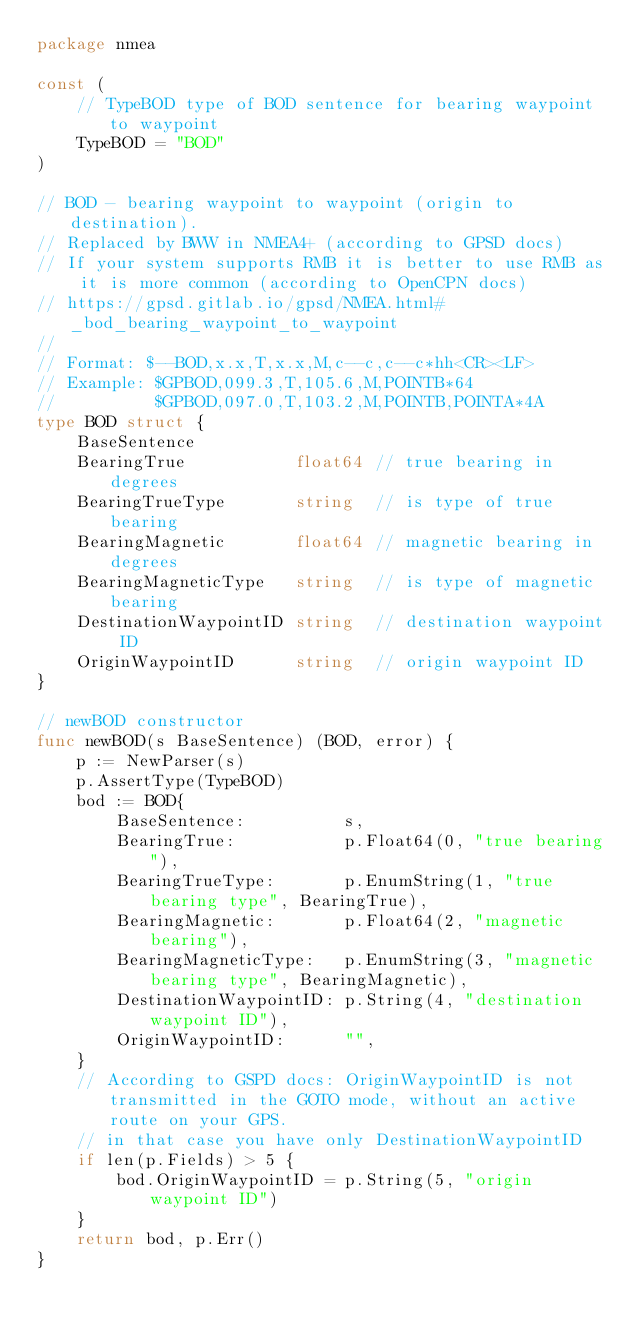Convert code to text. <code><loc_0><loc_0><loc_500><loc_500><_Go_>package nmea

const (
	// TypeBOD type of BOD sentence for bearing waypoint to waypoint
	TypeBOD = "BOD"
)

// BOD - bearing waypoint to waypoint (origin to destination).
// Replaced by BWW in NMEA4+ (according to GPSD docs)
// If your system supports RMB it is better to use RMB as it is more common (according to OpenCPN docs)
// https://gpsd.gitlab.io/gpsd/NMEA.html#_bod_bearing_waypoint_to_waypoint
//
// Format: $--BOD,x.x,T,x.x,M,c--c,c--c*hh<CR><LF>
// Example: $GPBOD,099.3,T,105.6,M,POINTB*64
//			$GPBOD,097.0,T,103.2,M,POINTB,POINTA*4A
type BOD struct {
	BaseSentence
	BearingTrue           float64 // true bearing in degrees
	BearingTrueType       string  // is type of true bearing
	BearingMagnetic       float64 // magnetic bearing in degrees
	BearingMagneticType   string  // is type of magnetic bearing
	DestinationWaypointID string  // destination waypoint ID
	OriginWaypointID      string  // origin waypoint ID
}

// newBOD constructor
func newBOD(s BaseSentence) (BOD, error) {
	p := NewParser(s)
	p.AssertType(TypeBOD)
	bod := BOD{
		BaseSentence:          s,
		BearingTrue:           p.Float64(0, "true bearing"),
		BearingTrueType:       p.EnumString(1, "true bearing type", BearingTrue),
		BearingMagnetic:       p.Float64(2, "magnetic bearing"),
		BearingMagneticType:   p.EnumString(3, "magnetic bearing type", BearingMagnetic),
		DestinationWaypointID: p.String(4, "destination waypoint ID"),
		OriginWaypointID:      "",
	}
	// According to GSPD docs: OriginWaypointID is not transmitted in the GOTO mode, without an active route on your GPS.
	// in that case you have only DestinationWaypointID
	if len(p.Fields) > 5 {
		bod.OriginWaypointID = p.String(5, "origin waypoint ID")
	}
	return bod, p.Err()
}
</code> 